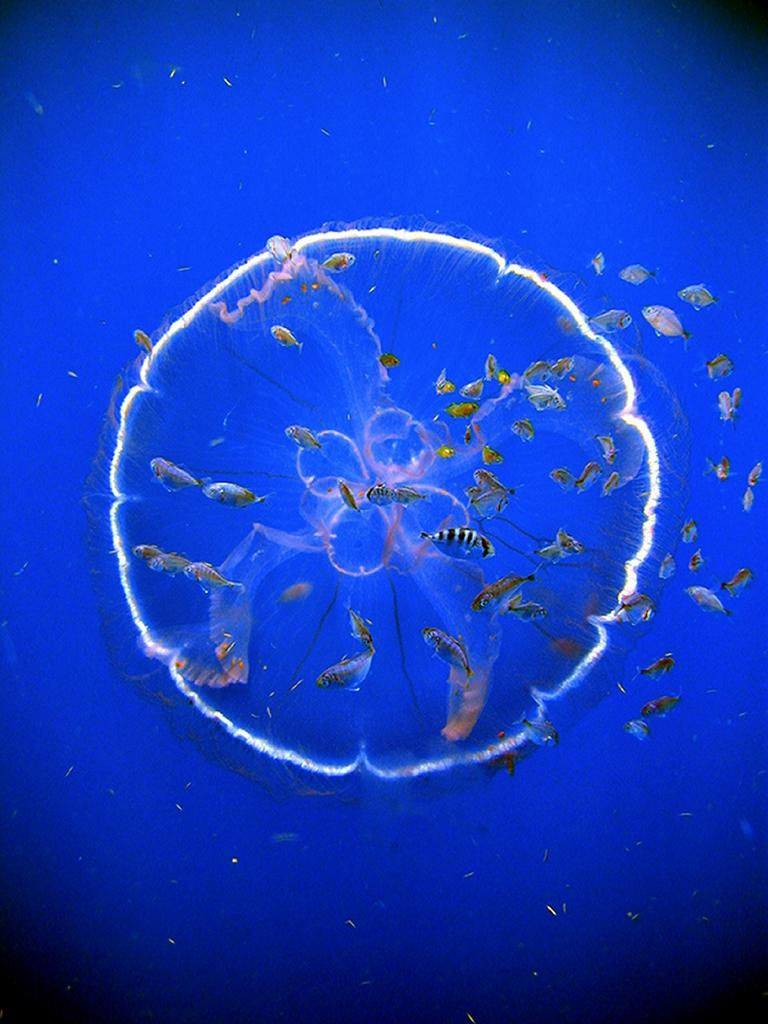Where was the image taken? The image is taken in the sea. What can be seen in the middle of the image? There is a jellyfish in the middle of the image. What other marine life is visible in the image? There are many fishes in the water. What type of coach can be seen in the image? There is no coach present in the image; it is taken in the sea and features marine life. 